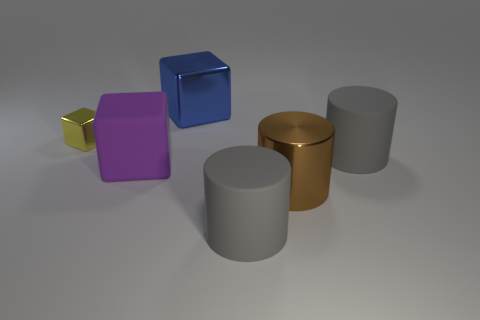How many objects are there in total, and can you describe their colors? There are six objects in total. Starting from the left, their colors are yellow, purple, blue, gold, and two are gray. 